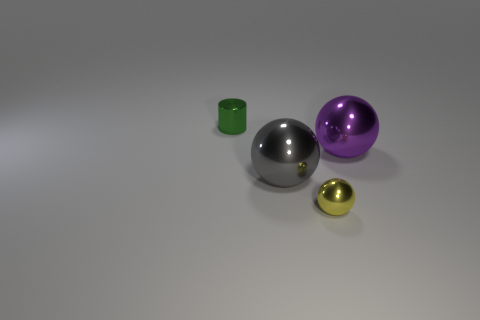What is the green object made of?
Make the answer very short. Metal. There is a large metallic thing that is in front of the purple shiny object; does it have the same shape as the small green metal object?
Offer a very short reply. No. What number of things are purple metal spheres or small yellow balls?
Keep it short and to the point. 2. How big is the cylinder?
Your answer should be compact. Small. What number of spheres are either large cyan objects or metallic objects?
Ensure brevity in your answer.  3. Is the number of yellow metallic balls in front of the small yellow shiny object the same as the number of yellow shiny things right of the purple sphere?
Offer a terse response. Yes. The purple metal object that is the same shape as the gray metallic thing is what size?
Make the answer very short. Large. There is a sphere that is both behind the small metal ball and right of the gray metallic object; what size is it?
Provide a succinct answer. Large. Are there any large gray things behind the tiny cylinder?
Give a very brief answer. No. What number of objects are objects that are on the right side of the small sphere or large purple metal objects?
Provide a short and direct response. 1. 